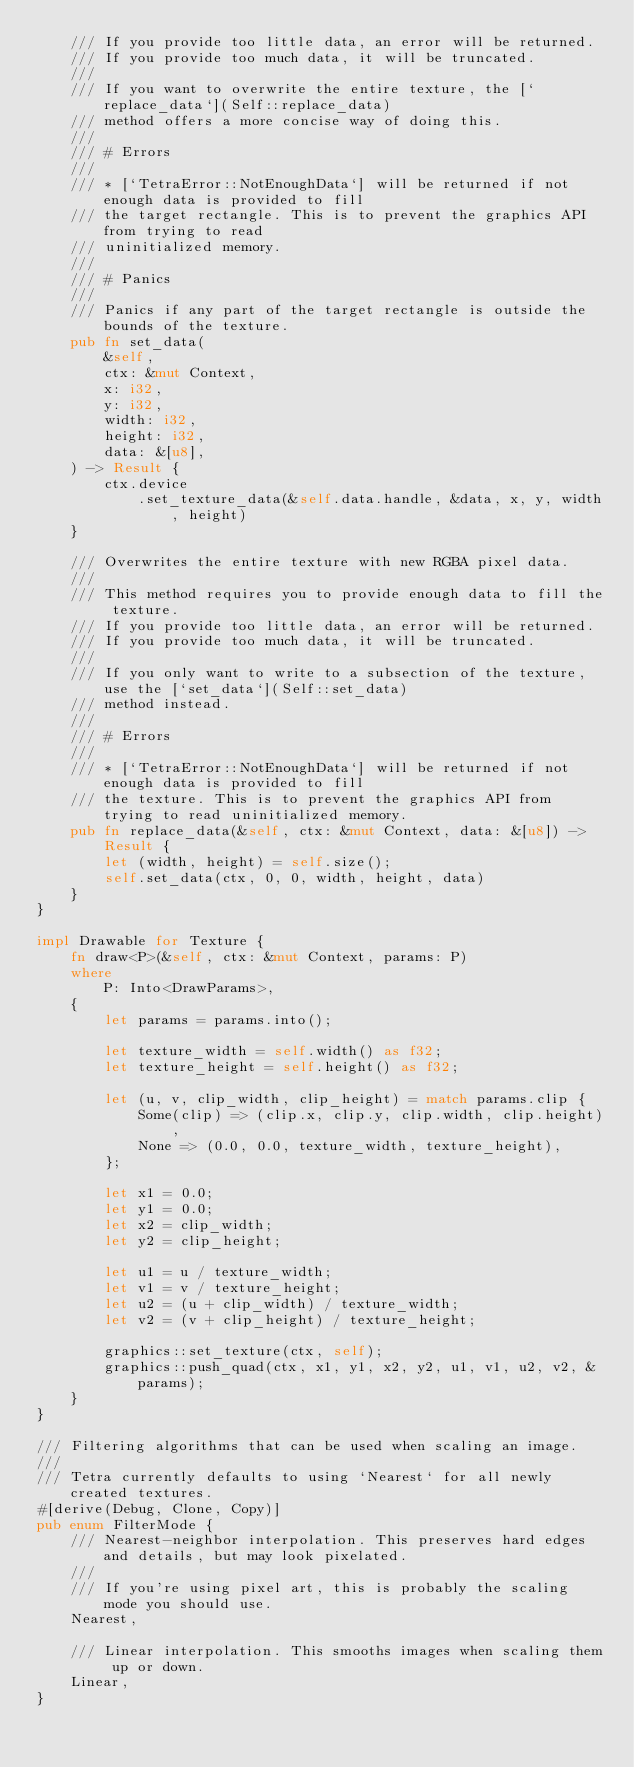<code> <loc_0><loc_0><loc_500><loc_500><_Rust_>    /// If you provide too little data, an error will be returned.
    /// If you provide too much data, it will be truncated.
    ///
    /// If you want to overwrite the entire texture, the [`replace_data`](Self::replace_data)
    /// method offers a more concise way of doing this.
    ///
    /// # Errors
    ///
    /// * [`TetraError::NotEnoughData`] will be returned if not enough data is provided to fill
    /// the target rectangle. This is to prevent the graphics API from trying to read
    /// uninitialized memory.
    ///
    /// # Panics
    ///
    /// Panics if any part of the target rectangle is outside the bounds of the texture.
    pub fn set_data(
        &self,
        ctx: &mut Context,
        x: i32,
        y: i32,
        width: i32,
        height: i32,
        data: &[u8],
    ) -> Result {
        ctx.device
            .set_texture_data(&self.data.handle, &data, x, y, width, height)
    }

    /// Overwrites the entire texture with new RGBA pixel data.
    ///
    /// This method requires you to provide enough data to fill the texture.
    /// If you provide too little data, an error will be returned.
    /// If you provide too much data, it will be truncated.
    ///
    /// If you only want to write to a subsection of the texture, use the [`set_data`](Self::set_data)
    /// method instead.
    ///
    /// # Errors
    ///
    /// * [`TetraError::NotEnoughData`] will be returned if not enough data is provided to fill
    /// the texture. This is to prevent the graphics API from trying to read uninitialized memory.
    pub fn replace_data(&self, ctx: &mut Context, data: &[u8]) -> Result {
        let (width, height) = self.size();
        self.set_data(ctx, 0, 0, width, height, data)
    }
}

impl Drawable for Texture {
    fn draw<P>(&self, ctx: &mut Context, params: P)
    where
        P: Into<DrawParams>,
    {
        let params = params.into();

        let texture_width = self.width() as f32;
        let texture_height = self.height() as f32;

        let (u, v, clip_width, clip_height) = match params.clip {
            Some(clip) => (clip.x, clip.y, clip.width, clip.height),
            None => (0.0, 0.0, texture_width, texture_height),
        };

        let x1 = 0.0;
        let y1 = 0.0;
        let x2 = clip_width;
        let y2 = clip_height;

        let u1 = u / texture_width;
        let v1 = v / texture_height;
        let u2 = (u + clip_width) / texture_width;
        let v2 = (v + clip_height) / texture_height;

        graphics::set_texture(ctx, self);
        graphics::push_quad(ctx, x1, y1, x2, y2, u1, v1, u2, v2, &params);
    }
}

/// Filtering algorithms that can be used when scaling an image.
///
/// Tetra currently defaults to using `Nearest` for all newly created textures.
#[derive(Debug, Clone, Copy)]
pub enum FilterMode {
    /// Nearest-neighbor interpolation. This preserves hard edges and details, but may look pixelated.
    ///
    /// If you're using pixel art, this is probably the scaling mode you should use.
    Nearest,

    /// Linear interpolation. This smooths images when scaling them up or down.
    Linear,
}
</code> 